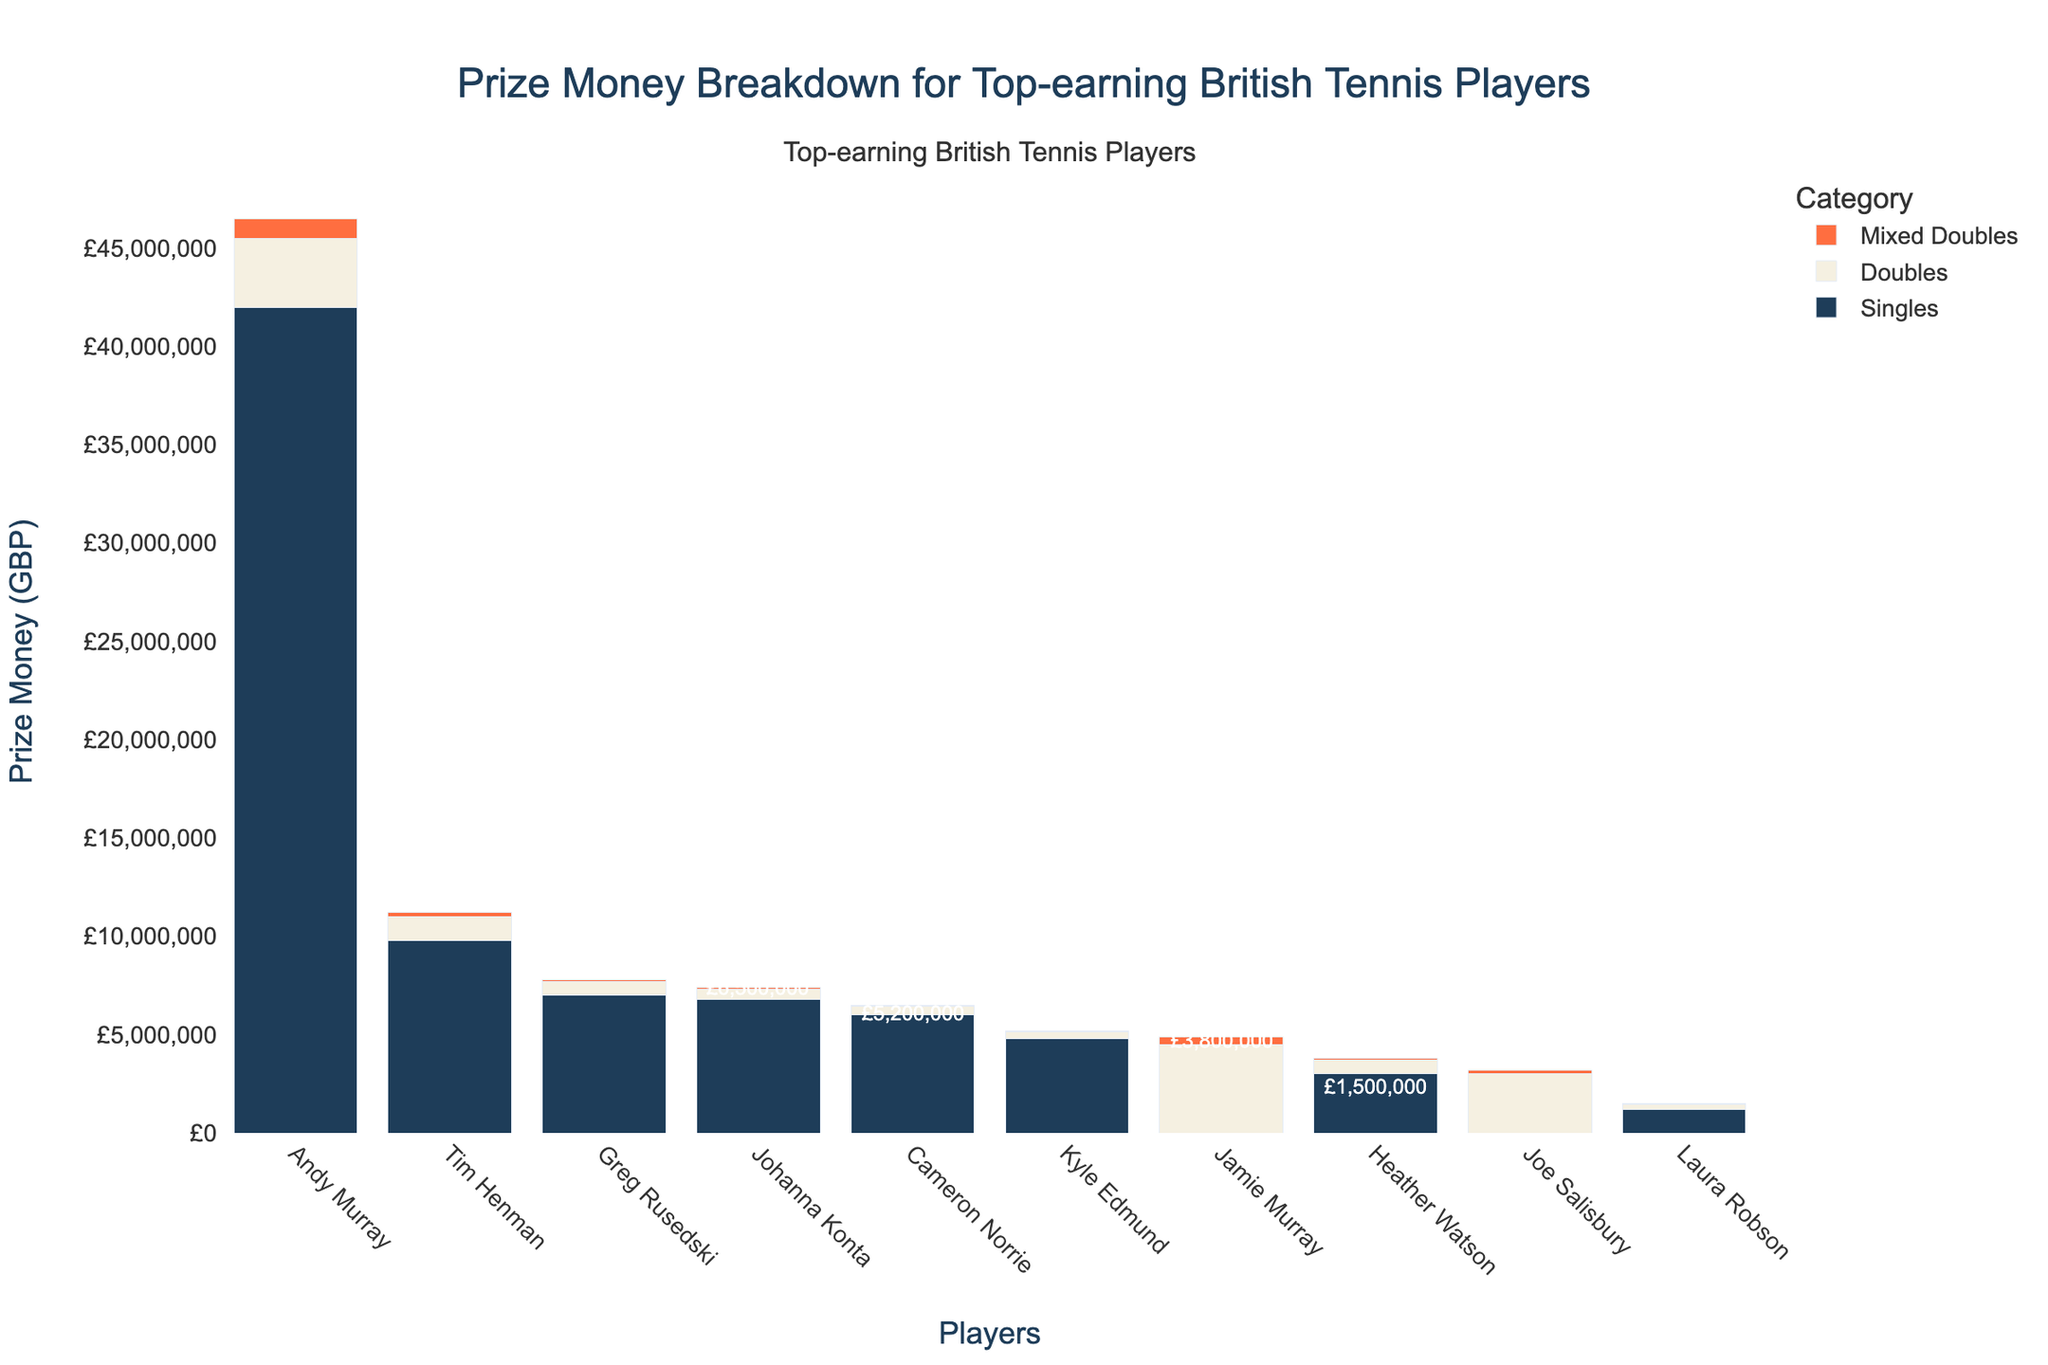Which player has earned the most prize money in total? Look at the total prize money breakdown (shown on top of each bar), and Andy Murray has the highest amount at £46,500,000.
Answer: Andy Murray Which category contributes most to Jamie Murray's prize money? Observe the segments of the bar representing Jamie Murray. The largest segment is the doubles prize money, indicated by its longest section among the three categories.
Answer: Doubles Who is the highest-earning female player in the chart, and what is her total prize money? Locate the female players (Johanna Konta, Heather Watson, Laura Robson) and identify their total earnings. Johanna Konta has the highest total prize money of £7,400,000 among them.
Answer: Johanna Konta, £7,400,000 What is the total singles prize money earned by Andy Murray and Tim Henman combined? Add Andy Murray's singles prize money (£42,000,000) to Tim Henman's singles prize money (£9,800,000). The result is £51,800,000.
Answer: £51,800,000 Who has earned more in mixed doubles: Heather Watson or Jamie Murray? Compare the mixed doubles segments of Heather Watson's (£100,000) and Jamie Murray's (£400,000) bars. Jamie Murray has earned more.
Answer: Jamie Murray Which player has the least total prize money, and how much is it? Look for the shortest bar representing the total prize money, which belongs to Laura Robson, with a total of £1,500,000.
Answer: Laura Robson, £1,500,000 How much more doubles prize money has Jamie Murray earned compared to Joe Salisbury? Subtract Joe Salisbury's doubles prize money (£3,000,000) from Jamie Murray's doubles prize money (£4,500,000), resulting in £1,500,000 more for Jamie Murray.
Answer: £1,500,000 Which player has a relatively balanced prize money across all three categories, and who might that be based on the bar lengths? Observe the bars where the three segments (singles, doubles, mixed doubles) are somewhat evenly distributed. Heather Watson has a relatively balanced distribution with almost equal lengths across the three categories.
Answer: Heather Watson 